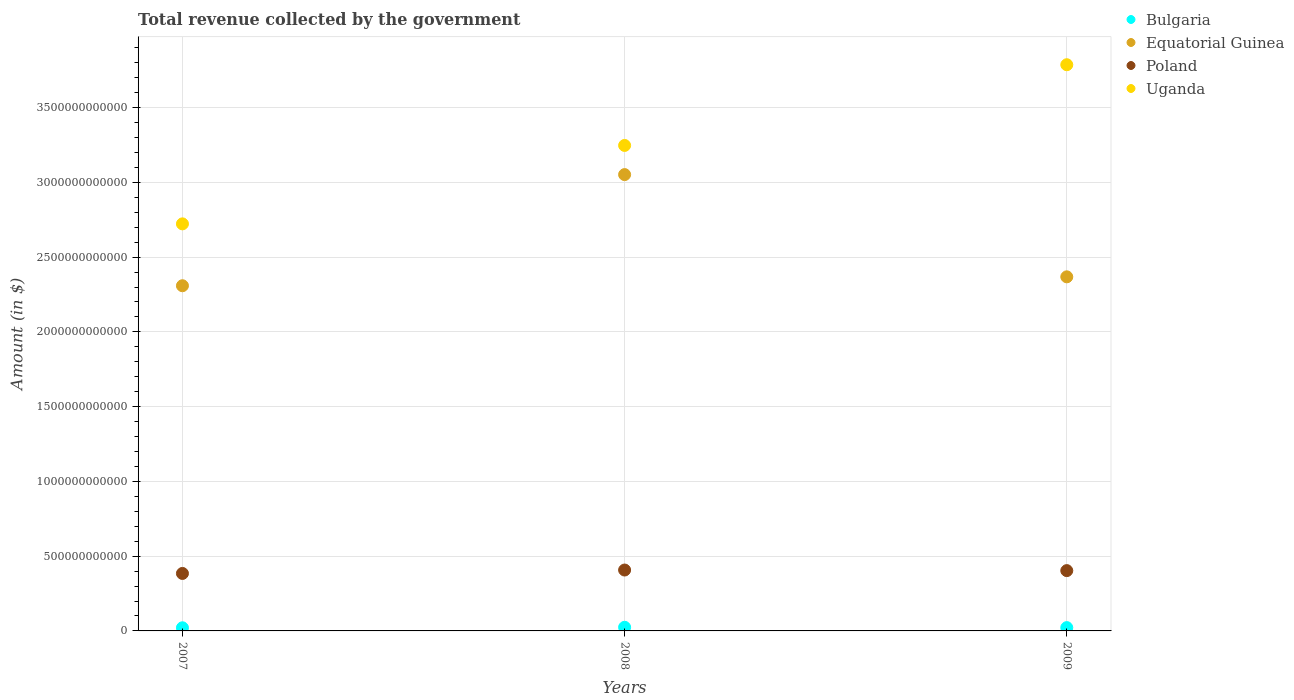How many different coloured dotlines are there?
Make the answer very short. 4. Is the number of dotlines equal to the number of legend labels?
Keep it short and to the point. Yes. What is the total revenue collected by the government in Bulgaria in 2007?
Your answer should be very brief. 2.10e+1. Across all years, what is the maximum total revenue collected by the government in Equatorial Guinea?
Ensure brevity in your answer.  3.05e+12. Across all years, what is the minimum total revenue collected by the government in Equatorial Guinea?
Your response must be concise. 2.31e+12. What is the total total revenue collected by the government in Bulgaria in the graph?
Provide a succinct answer. 6.74e+1. What is the difference between the total revenue collected by the government in Poland in 2007 and that in 2008?
Provide a succinct answer. -2.29e+1. What is the difference between the total revenue collected by the government in Uganda in 2007 and the total revenue collected by the government in Equatorial Guinea in 2009?
Your response must be concise. 3.54e+11. What is the average total revenue collected by the government in Poland per year?
Your answer should be very brief. 3.98e+11. In the year 2008, what is the difference between the total revenue collected by the government in Equatorial Guinea and total revenue collected by the government in Bulgaria?
Your answer should be very brief. 3.03e+12. In how many years, is the total revenue collected by the government in Poland greater than 3800000000000 $?
Provide a succinct answer. 0. What is the ratio of the total revenue collected by the government in Bulgaria in 2008 to that in 2009?
Offer a terse response. 1.1. What is the difference between the highest and the second highest total revenue collected by the government in Uganda?
Give a very brief answer. 5.40e+11. What is the difference between the highest and the lowest total revenue collected by the government in Equatorial Guinea?
Give a very brief answer. 7.43e+11. In how many years, is the total revenue collected by the government in Poland greater than the average total revenue collected by the government in Poland taken over all years?
Make the answer very short. 2. Is it the case that in every year, the sum of the total revenue collected by the government in Bulgaria and total revenue collected by the government in Equatorial Guinea  is greater than the sum of total revenue collected by the government in Poland and total revenue collected by the government in Uganda?
Your answer should be compact. Yes. Is it the case that in every year, the sum of the total revenue collected by the government in Equatorial Guinea and total revenue collected by the government in Uganda  is greater than the total revenue collected by the government in Poland?
Keep it short and to the point. Yes. Does the total revenue collected by the government in Bulgaria monotonically increase over the years?
Ensure brevity in your answer.  No. Is the total revenue collected by the government in Poland strictly less than the total revenue collected by the government in Uganda over the years?
Your answer should be very brief. Yes. How many years are there in the graph?
Keep it short and to the point. 3. What is the difference between two consecutive major ticks on the Y-axis?
Make the answer very short. 5.00e+11. Does the graph contain grids?
Your response must be concise. Yes. Where does the legend appear in the graph?
Your answer should be very brief. Top right. How many legend labels are there?
Offer a very short reply. 4. What is the title of the graph?
Provide a succinct answer. Total revenue collected by the government. Does "Syrian Arab Republic" appear as one of the legend labels in the graph?
Provide a short and direct response. No. What is the label or title of the X-axis?
Make the answer very short. Years. What is the label or title of the Y-axis?
Provide a short and direct response. Amount (in $). What is the Amount (in $) of Bulgaria in 2007?
Make the answer very short. 2.10e+1. What is the Amount (in $) of Equatorial Guinea in 2007?
Offer a terse response. 2.31e+12. What is the Amount (in $) of Poland in 2007?
Your answer should be compact. 3.84e+11. What is the Amount (in $) in Uganda in 2007?
Your response must be concise. 2.72e+12. What is the Amount (in $) of Bulgaria in 2008?
Give a very brief answer. 2.43e+1. What is the Amount (in $) in Equatorial Guinea in 2008?
Your answer should be compact. 3.05e+12. What is the Amount (in $) of Poland in 2008?
Provide a succinct answer. 4.07e+11. What is the Amount (in $) in Uganda in 2008?
Provide a short and direct response. 3.25e+12. What is the Amount (in $) of Bulgaria in 2009?
Offer a very short reply. 2.21e+1. What is the Amount (in $) in Equatorial Guinea in 2009?
Offer a very short reply. 2.37e+12. What is the Amount (in $) in Poland in 2009?
Give a very brief answer. 4.03e+11. What is the Amount (in $) of Uganda in 2009?
Give a very brief answer. 3.79e+12. Across all years, what is the maximum Amount (in $) of Bulgaria?
Your answer should be compact. 2.43e+1. Across all years, what is the maximum Amount (in $) in Equatorial Guinea?
Your answer should be very brief. 3.05e+12. Across all years, what is the maximum Amount (in $) in Poland?
Make the answer very short. 4.07e+11. Across all years, what is the maximum Amount (in $) in Uganda?
Give a very brief answer. 3.79e+12. Across all years, what is the minimum Amount (in $) of Bulgaria?
Offer a very short reply. 2.10e+1. Across all years, what is the minimum Amount (in $) of Equatorial Guinea?
Offer a terse response. 2.31e+12. Across all years, what is the minimum Amount (in $) of Poland?
Provide a short and direct response. 3.84e+11. Across all years, what is the minimum Amount (in $) of Uganda?
Your answer should be very brief. 2.72e+12. What is the total Amount (in $) of Bulgaria in the graph?
Keep it short and to the point. 6.74e+1. What is the total Amount (in $) in Equatorial Guinea in the graph?
Your answer should be very brief. 7.73e+12. What is the total Amount (in $) in Poland in the graph?
Provide a succinct answer. 1.19e+12. What is the total Amount (in $) in Uganda in the graph?
Your response must be concise. 9.76e+12. What is the difference between the Amount (in $) of Bulgaria in 2007 and that in 2008?
Make the answer very short. -3.26e+09. What is the difference between the Amount (in $) in Equatorial Guinea in 2007 and that in 2008?
Ensure brevity in your answer.  -7.43e+11. What is the difference between the Amount (in $) in Poland in 2007 and that in 2008?
Offer a very short reply. -2.29e+1. What is the difference between the Amount (in $) in Uganda in 2007 and that in 2008?
Ensure brevity in your answer.  -5.24e+11. What is the difference between the Amount (in $) in Bulgaria in 2007 and that in 2009?
Ensure brevity in your answer.  -1.13e+09. What is the difference between the Amount (in $) in Equatorial Guinea in 2007 and that in 2009?
Make the answer very short. -5.96e+1. What is the difference between the Amount (in $) in Poland in 2007 and that in 2009?
Make the answer very short. -1.89e+1. What is the difference between the Amount (in $) of Uganda in 2007 and that in 2009?
Make the answer very short. -1.06e+12. What is the difference between the Amount (in $) of Bulgaria in 2008 and that in 2009?
Your answer should be compact. 2.13e+09. What is the difference between the Amount (in $) of Equatorial Guinea in 2008 and that in 2009?
Provide a short and direct response. 6.84e+11. What is the difference between the Amount (in $) of Poland in 2008 and that in 2009?
Offer a terse response. 3.95e+09. What is the difference between the Amount (in $) in Uganda in 2008 and that in 2009?
Offer a terse response. -5.40e+11. What is the difference between the Amount (in $) in Bulgaria in 2007 and the Amount (in $) in Equatorial Guinea in 2008?
Your response must be concise. -3.03e+12. What is the difference between the Amount (in $) of Bulgaria in 2007 and the Amount (in $) of Poland in 2008?
Provide a short and direct response. -3.86e+11. What is the difference between the Amount (in $) of Bulgaria in 2007 and the Amount (in $) of Uganda in 2008?
Provide a short and direct response. -3.23e+12. What is the difference between the Amount (in $) in Equatorial Guinea in 2007 and the Amount (in $) in Poland in 2008?
Offer a very short reply. 1.90e+12. What is the difference between the Amount (in $) in Equatorial Guinea in 2007 and the Amount (in $) in Uganda in 2008?
Your answer should be compact. -9.38e+11. What is the difference between the Amount (in $) in Poland in 2007 and the Amount (in $) in Uganda in 2008?
Give a very brief answer. -2.86e+12. What is the difference between the Amount (in $) in Bulgaria in 2007 and the Amount (in $) in Equatorial Guinea in 2009?
Your answer should be compact. -2.35e+12. What is the difference between the Amount (in $) of Bulgaria in 2007 and the Amount (in $) of Poland in 2009?
Offer a terse response. -3.82e+11. What is the difference between the Amount (in $) in Bulgaria in 2007 and the Amount (in $) in Uganda in 2009?
Ensure brevity in your answer.  -3.77e+12. What is the difference between the Amount (in $) of Equatorial Guinea in 2007 and the Amount (in $) of Poland in 2009?
Your answer should be compact. 1.91e+12. What is the difference between the Amount (in $) of Equatorial Guinea in 2007 and the Amount (in $) of Uganda in 2009?
Give a very brief answer. -1.48e+12. What is the difference between the Amount (in $) in Poland in 2007 and the Amount (in $) in Uganda in 2009?
Your response must be concise. -3.40e+12. What is the difference between the Amount (in $) in Bulgaria in 2008 and the Amount (in $) in Equatorial Guinea in 2009?
Your answer should be compact. -2.34e+12. What is the difference between the Amount (in $) of Bulgaria in 2008 and the Amount (in $) of Poland in 2009?
Give a very brief answer. -3.79e+11. What is the difference between the Amount (in $) of Bulgaria in 2008 and the Amount (in $) of Uganda in 2009?
Offer a terse response. -3.76e+12. What is the difference between the Amount (in $) in Equatorial Guinea in 2008 and the Amount (in $) in Poland in 2009?
Keep it short and to the point. 2.65e+12. What is the difference between the Amount (in $) in Equatorial Guinea in 2008 and the Amount (in $) in Uganda in 2009?
Your answer should be very brief. -7.35e+11. What is the difference between the Amount (in $) in Poland in 2008 and the Amount (in $) in Uganda in 2009?
Provide a succinct answer. -3.38e+12. What is the average Amount (in $) of Bulgaria per year?
Provide a succinct answer. 2.25e+1. What is the average Amount (in $) of Equatorial Guinea per year?
Your answer should be very brief. 2.58e+12. What is the average Amount (in $) of Poland per year?
Keep it short and to the point. 3.98e+11. What is the average Amount (in $) in Uganda per year?
Give a very brief answer. 3.25e+12. In the year 2007, what is the difference between the Amount (in $) of Bulgaria and Amount (in $) of Equatorial Guinea?
Provide a short and direct response. -2.29e+12. In the year 2007, what is the difference between the Amount (in $) in Bulgaria and Amount (in $) in Poland?
Make the answer very short. -3.63e+11. In the year 2007, what is the difference between the Amount (in $) of Bulgaria and Amount (in $) of Uganda?
Your answer should be very brief. -2.70e+12. In the year 2007, what is the difference between the Amount (in $) of Equatorial Guinea and Amount (in $) of Poland?
Your answer should be compact. 1.92e+12. In the year 2007, what is the difference between the Amount (in $) in Equatorial Guinea and Amount (in $) in Uganda?
Provide a short and direct response. -4.14e+11. In the year 2007, what is the difference between the Amount (in $) in Poland and Amount (in $) in Uganda?
Your response must be concise. -2.34e+12. In the year 2008, what is the difference between the Amount (in $) in Bulgaria and Amount (in $) in Equatorial Guinea?
Give a very brief answer. -3.03e+12. In the year 2008, what is the difference between the Amount (in $) in Bulgaria and Amount (in $) in Poland?
Give a very brief answer. -3.83e+11. In the year 2008, what is the difference between the Amount (in $) of Bulgaria and Amount (in $) of Uganda?
Keep it short and to the point. -3.22e+12. In the year 2008, what is the difference between the Amount (in $) in Equatorial Guinea and Amount (in $) in Poland?
Your answer should be very brief. 2.64e+12. In the year 2008, what is the difference between the Amount (in $) in Equatorial Guinea and Amount (in $) in Uganda?
Offer a very short reply. -1.95e+11. In the year 2008, what is the difference between the Amount (in $) of Poland and Amount (in $) of Uganda?
Ensure brevity in your answer.  -2.84e+12. In the year 2009, what is the difference between the Amount (in $) of Bulgaria and Amount (in $) of Equatorial Guinea?
Provide a short and direct response. -2.35e+12. In the year 2009, what is the difference between the Amount (in $) of Bulgaria and Amount (in $) of Poland?
Your answer should be very brief. -3.81e+11. In the year 2009, what is the difference between the Amount (in $) in Bulgaria and Amount (in $) in Uganda?
Offer a very short reply. -3.76e+12. In the year 2009, what is the difference between the Amount (in $) of Equatorial Guinea and Amount (in $) of Poland?
Make the answer very short. 1.96e+12. In the year 2009, what is the difference between the Amount (in $) in Equatorial Guinea and Amount (in $) in Uganda?
Provide a short and direct response. -1.42e+12. In the year 2009, what is the difference between the Amount (in $) in Poland and Amount (in $) in Uganda?
Offer a terse response. -3.38e+12. What is the ratio of the Amount (in $) of Bulgaria in 2007 to that in 2008?
Offer a very short reply. 0.87. What is the ratio of the Amount (in $) in Equatorial Guinea in 2007 to that in 2008?
Give a very brief answer. 0.76. What is the ratio of the Amount (in $) of Poland in 2007 to that in 2008?
Ensure brevity in your answer.  0.94. What is the ratio of the Amount (in $) in Uganda in 2007 to that in 2008?
Your response must be concise. 0.84. What is the ratio of the Amount (in $) of Bulgaria in 2007 to that in 2009?
Your answer should be compact. 0.95. What is the ratio of the Amount (in $) of Equatorial Guinea in 2007 to that in 2009?
Your answer should be very brief. 0.97. What is the ratio of the Amount (in $) of Poland in 2007 to that in 2009?
Provide a short and direct response. 0.95. What is the ratio of the Amount (in $) in Uganda in 2007 to that in 2009?
Make the answer very short. 0.72. What is the ratio of the Amount (in $) in Bulgaria in 2008 to that in 2009?
Provide a succinct answer. 1.1. What is the ratio of the Amount (in $) of Equatorial Guinea in 2008 to that in 2009?
Provide a succinct answer. 1.29. What is the ratio of the Amount (in $) of Poland in 2008 to that in 2009?
Offer a terse response. 1.01. What is the ratio of the Amount (in $) in Uganda in 2008 to that in 2009?
Your answer should be very brief. 0.86. What is the difference between the highest and the second highest Amount (in $) of Bulgaria?
Keep it short and to the point. 2.13e+09. What is the difference between the highest and the second highest Amount (in $) in Equatorial Guinea?
Make the answer very short. 6.84e+11. What is the difference between the highest and the second highest Amount (in $) of Poland?
Ensure brevity in your answer.  3.95e+09. What is the difference between the highest and the second highest Amount (in $) of Uganda?
Offer a very short reply. 5.40e+11. What is the difference between the highest and the lowest Amount (in $) of Bulgaria?
Provide a succinct answer. 3.26e+09. What is the difference between the highest and the lowest Amount (in $) in Equatorial Guinea?
Ensure brevity in your answer.  7.43e+11. What is the difference between the highest and the lowest Amount (in $) in Poland?
Provide a short and direct response. 2.29e+1. What is the difference between the highest and the lowest Amount (in $) in Uganda?
Your answer should be compact. 1.06e+12. 